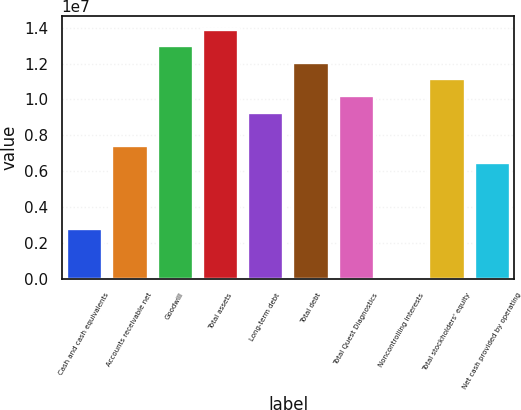<chart> <loc_0><loc_0><loc_500><loc_500><bar_chart><fcel>Cash and cash equivalents<fcel>Accounts receivable net<fcel>Goodwill<fcel>Total assets<fcel>Long-term debt<fcel>Total debt<fcel>Total Quest Diagnostics<fcel>Noncontrolling interests<fcel>Total stockholders' equity<fcel>Net cash provided by operating<nl><fcel>2.8095e+06<fcel>7.45513e+06<fcel>1.30299e+07<fcel>1.3959e+07<fcel>9.31338e+06<fcel>1.21008e+07<fcel>1.02425e+07<fcel>22127<fcel>1.11716e+07<fcel>6.526e+06<nl></chart> 